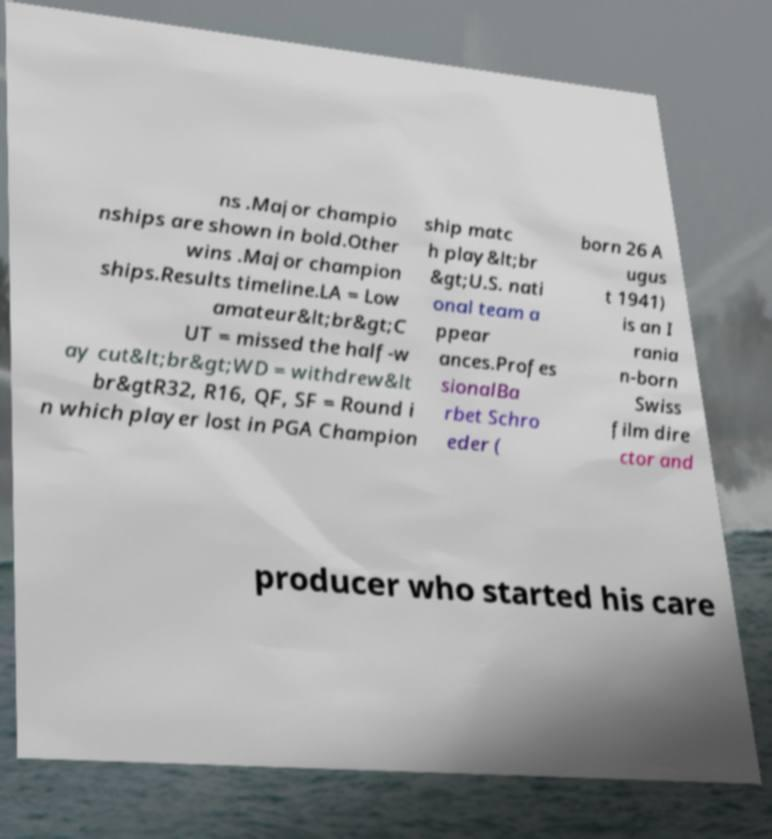Please identify and transcribe the text found in this image. ns .Major champio nships are shown in bold.Other wins .Major champion ships.Results timeline.LA = Low amateur&lt;br&gt;C UT = missed the half-w ay cut&lt;br&gt;WD = withdrew&lt br&gtR32, R16, QF, SF = Round i n which player lost in PGA Champion ship matc h play&lt;br &gt;U.S. nati onal team a ppear ances.Profes sionalBa rbet Schro eder ( born 26 A ugus t 1941) is an I rania n-born Swiss film dire ctor and producer who started his care 